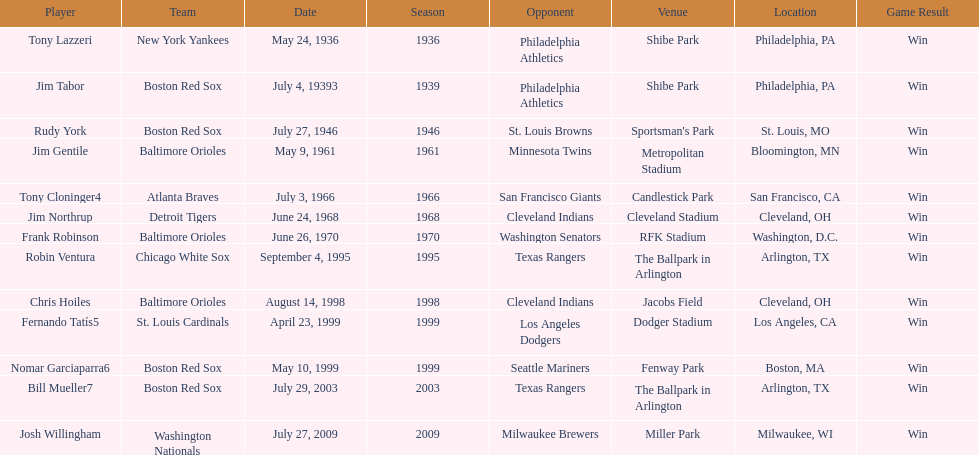Who is the first major league hitter to hit two grand slams in one game? Tony Lazzeri. 